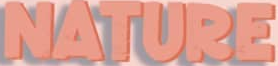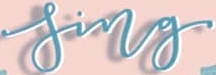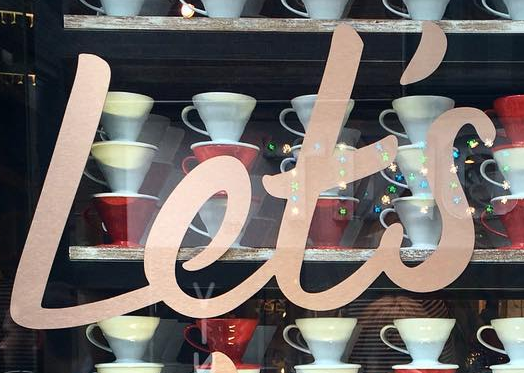What words are shown in these images in order, separated by a semicolon? NATURE; sing; Let's 